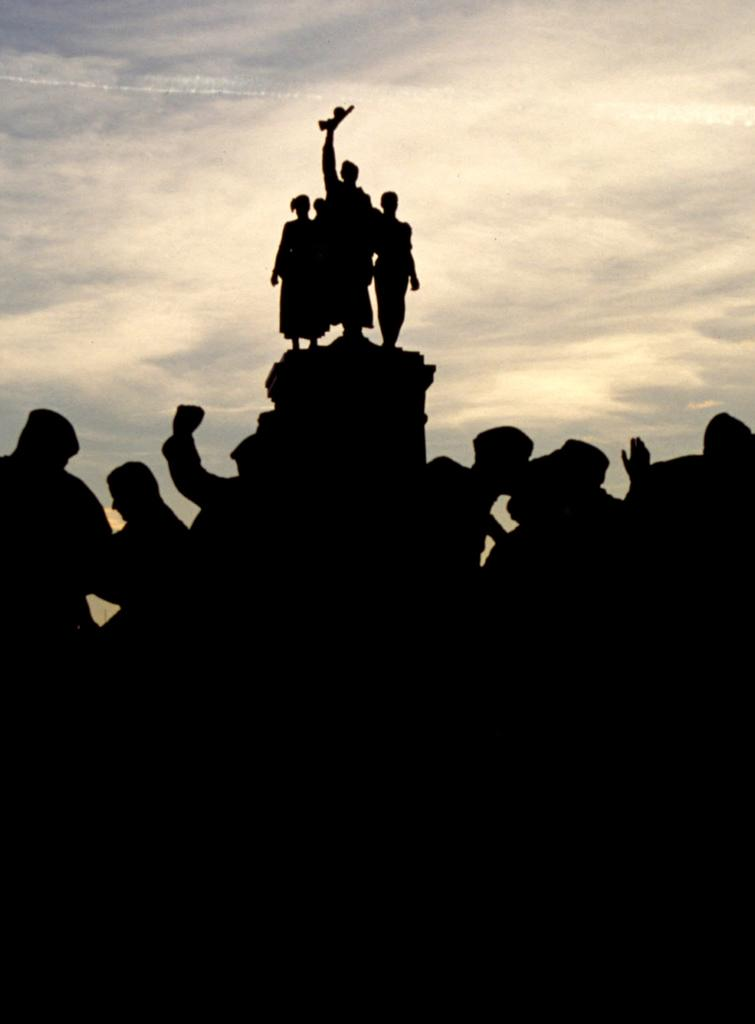What type of objects can be seen in the image? There are statues in the image. What can be seen in the background of the image? The sky is visible in the background of the image. How much knowledge can be gained from the store in the image? There is no store present in the image, so it is not possible to gain knowledge from it. 